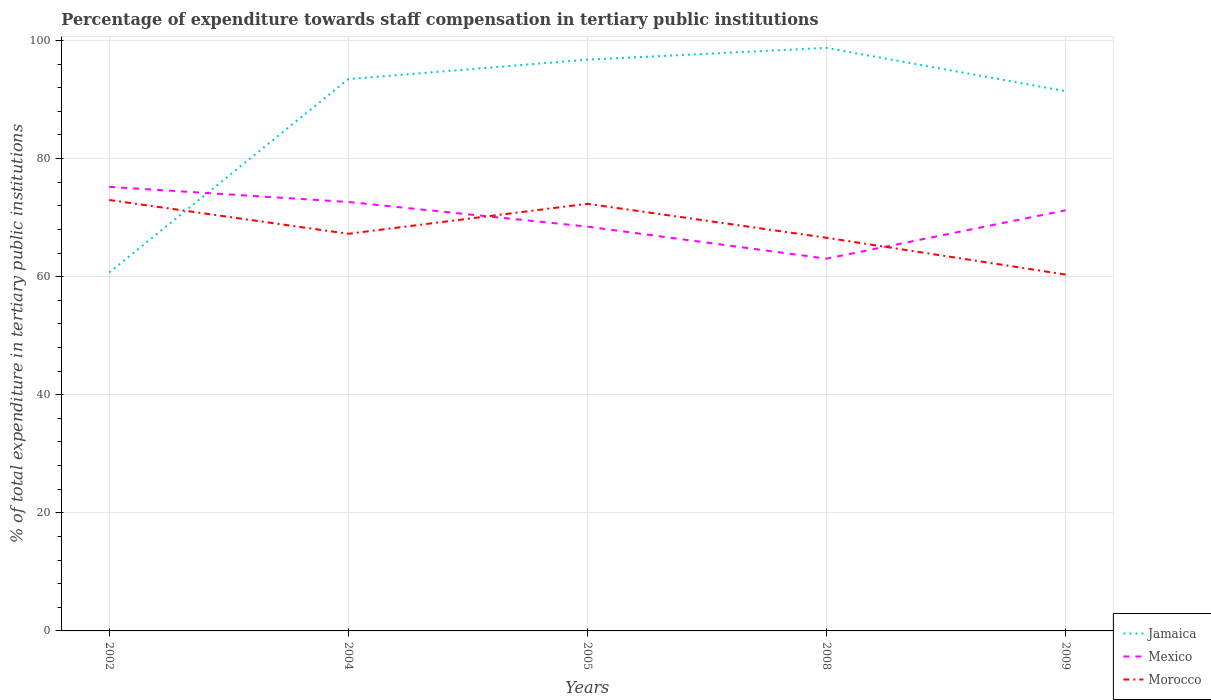How many different coloured lines are there?
Provide a short and direct response. 3. Does the line corresponding to Jamaica intersect with the line corresponding to Morocco?
Provide a short and direct response. Yes. Is the number of lines equal to the number of legend labels?
Offer a very short reply. Yes. Across all years, what is the maximum percentage of expenditure towards staff compensation in Jamaica?
Offer a very short reply. 60.7. What is the total percentage of expenditure towards staff compensation in Mexico in the graph?
Offer a terse response. -2.76. What is the difference between the highest and the second highest percentage of expenditure towards staff compensation in Mexico?
Give a very brief answer. 12.16. How many lines are there?
Your answer should be compact. 3. Are the values on the major ticks of Y-axis written in scientific E-notation?
Your answer should be very brief. No. Does the graph contain any zero values?
Provide a succinct answer. No. Does the graph contain grids?
Give a very brief answer. Yes. How many legend labels are there?
Make the answer very short. 3. What is the title of the graph?
Your response must be concise. Percentage of expenditure towards staff compensation in tertiary public institutions. What is the label or title of the X-axis?
Provide a succinct answer. Years. What is the label or title of the Y-axis?
Provide a succinct answer. % of total expenditure in tertiary public institutions. What is the % of total expenditure in tertiary public institutions in Jamaica in 2002?
Provide a succinct answer. 60.7. What is the % of total expenditure in tertiary public institutions in Mexico in 2002?
Your answer should be compact. 75.21. What is the % of total expenditure in tertiary public institutions in Morocco in 2002?
Offer a very short reply. 72.98. What is the % of total expenditure in tertiary public institutions in Jamaica in 2004?
Provide a succinct answer. 93.46. What is the % of total expenditure in tertiary public institutions in Mexico in 2004?
Provide a succinct answer. 72.65. What is the % of total expenditure in tertiary public institutions in Morocco in 2004?
Offer a terse response. 67.26. What is the % of total expenditure in tertiary public institutions in Jamaica in 2005?
Make the answer very short. 96.75. What is the % of total expenditure in tertiary public institutions of Mexico in 2005?
Make the answer very short. 68.47. What is the % of total expenditure in tertiary public institutions of Morocco in 2005?
Offer a terse response. 72.34. What is the % of total expenditure in tertiary public institutions of Jamaica in 2008?
Give a very brief answer. 98.74. What is the % of total expenditure in tertiary public institutions in Mexico in 2008?
Give a very brief answer. 63.05. What is the % of total expenditure in tertiary public institutions in Morocco in 2008?
Keep it short and to the point. 66.59. What is the % of total expenditure in tertiary public institutions of Jamaica in 2009?
Provide a short and direct response. 91.41. What is the % of total expenditure in tertiary public institutions of Mexico in 2009?
Your response must be concise. 71.23. What is the % of total expenditure in tertiary public institutions in Morocco in 2009?
Your response must be concise. 60.36. Across all years, what is the maximum % of total expenditure in tertiary public institutions in Jamaica?
Your response must be concise. 98.74. Across all years, what is the maximum % of total expenditure in tertiary public institutions of Mexico?
Offer a terse response. 75.21. Across all years, what is the maximum % of total expenditure in tertiary public institutions in Morocco?
Make the answer very short. 72.98. Across all years, what is the minimum % of total expenditure in tertiary public institutions in Jamaica?
Make the answer very short. 60.7. Across all years, what is the minimum % of total expenditure in tertiary public institutions of Mexico?
Make the answer very short. 63.05. Across all years, what is the minimum % of total expenditure in tertiary public institutions in Morocco?
Your response must be concise. 60.36. What is the total % of total expenditure in tertiary public institutions in Jamaica in the graph?
Make the answer very short. 441.06. What is the total % of total expenditure in tertiary public institutions of Mexico in the graph?
Give a very brief answer. 350.61. What is the total % of total expenditure in tertiary public institutions of Morocco in the graph?
Provide a short and direct response. 339.52. What is the difference between the % of total expenditure in tertiary public institutions of Jamaica in 2002 and that in 2004?
Make the answer very short. -32.75. What is the difference between the % of total expenditure in tertiary public institutions in Mexico in 2002 and that in 2004?
Offer a terse response. 2.56. What is the difference between the % of total expenditure in tertiary public institutions of Morocco in 2002 and that in 2004?
Keep it short and to the point. 5.72. What is the difference between the % of total expenditure in tertiary public institutions in Jamaica in 2002 and that in 2005?
Give a very brief answer. -36.05. What is the difference between the % of total expenditure in tertiary public institutions in Mexico in 2002 and that in 2005?
Offer a terse response. 6.74. What is the difference between the % of total expenditure in tertiary public institutions of Morocco in 2002 and that in 2005?
Ensure brevity in your answer.  0.64. What is the difference between the % of total expenditure in tertiary public institutions of Jamaica in 2002 and that in 2008?
Provide a succinct answer. -38.04. What is the difference between the % of total expenditure in tertiary public institutions in Mexico in 2002 and that in 2008?
Provide a succinct answer. 12.16. What is the difference between the % of total expenditure in tertiary public institutions in Morocco in 2002 and that in 2008?
Keep it short and to the point. 6.39. What is the difference between the % of total expenditure in tertiary public institutions in Jamaica in 2002 and that in 2009?
Give a very brief answer. -30.71. What is the difference between the % of total expenditure in tertiary public institutions in Mexico in 2002 and that in 2009?
Offer a very short reply. 3.98. What is the difference between the % of total expenditure in tertiary public institutions of Morocco in 2002 and that in 2009?
Offer a terse response. 12.62. What is the difference between the % of total expenditure in tertiary public institutions of Jamaica in 2004 and that in 2005?
Keep it short and to the point. -3.3. What is the difference between the % of total expenditure in tertiary public institutions in Mexico in 2004 and that in 2005?
Your answer should be compact. 4.17. What is the difference between the % of total expenditure in tertiary public institutions in Morocco in 2004 and that in 2005?
Your answer should be very brief. -5.08. What is the difference between the % of total expenditure in tertiary public institutions of Jamaica in 2004 and that in 2008?
Offer a terse response. -5.28. What is the difference between the % of total expenditure in tertiary public institutions in Mexico in 2004 and that in 2008?
Your answer should be compact. 9.6. What is the difference between the % of total expenditure in tertiary public institutions of Morocco in 2004 and that in 2008?
Provide a short and direct response. 0.67. What is the difference between the % of total expenditure in tertiary public institutions of Jamaica in 2004 and that in 2009?
Your answer should be compact. 2.04. What is the difference between the % of total expenditure in tertiary public institutions in Mexico in 2004 and that in 2009?
Make the answer very short. 1.41. What is the difference between the % of total expenditure in tertiary public institutions in Morocco in 2004 and that in 2009?
Your response must be concise. 6.9. What is the difference between the % of total expenditure in tertiary public institutions in Jamaica in 2005 and that in 2008?
Provide a succinct answer. -1.99. What is the difference between the % of total expenditure in tertiary public institutions in Mexico in 2005 and that in 2008?
Provide a succinct answer. 5.42. What is the difference between the % of total expenditure in tertiary public institutions in Morocco in 2005 and that in 2008?
Your response must be concise. 5.75. What is the difference between the % of total expenditure in tertiary public institutions in Jamaica in 2005 and that in 2009?
Your answer should be very brief. 5.34. What is the difference between the % of total expenditure in tertiary public institutions of Mexico in 2005 and that in 2009?
Provide a succinct answer. -2.76. What is the difference between the % of total expenditure in tertiary public institutions of Morocco in 2005 and that in 2009?
Your response must be concise. 11.98. What is the difference between the % of total expenditure in tertiary public institutions of Jamaica in 2008 and that in 2009?
Offer a terse response. 7.32. What is the difference between the % of total expenditure in tertiary public institutions in Mexico in 2008 and that in 2009?
Provide a succinct answer. -8.18. What is the difference between the % of total expenditure in tertiary public institutions in Morocco in 2008 and that in 2009?
Give a very brief answer. 6.23. What is the difference between the % of total expenditure in tertiary public institutions in Jamaica in 2002 and the % of total expenditure in tertiary public institutions in Mexico in 2004?
Provide a succinct answer. -11.95. What is the difference between the % of total expenditure in tertiary public institutions of Jamaica in 2002 and the % of total expenditure in tertiary public institutions of Morocco in 2004?
Your response must be concise. -6.56. What is the difference between the % of total expenditure in tertiary public institutions in Mexico in 2002 and the % of total expenditure in tertiary public institutions in Morocco in 2004?
Make the answer very short. 7.95. What is the difference between the % of total expenditure in tertiary public institutions in Jamaica in 2002 and the % of total expenditure in tertiary public institutions in Mexico in 2005?
Ensure brevity in your answer.  -7.77. What is the difference between the % of total expenditure in tertiary public institutions in Jamaica in 2002 and the % of total expenditure in tertiary public institutions in Morocco in 2005?
Keep it short and to the point. -11.64. What is the difference between the % of total expenditure in tertiary public institutions in Mexico in 2002 and the % of total expenditure in tertiary public institutions in Morocco in 2005?
Provide a short and direct response. 2.87. What is the difference between the % of total expenditure in tertiary public institutions in Jamaica in 2002 and the % of total expenditure in tertiary public institutions in Mexico in 2008?
Your answer should be very brief. -2.35. What is the difference between the % of total expenditure in tertiary public institutions in Jamaica in 2002 and the % of total expenditure in tertiary public institutions in Morocco in 2008?
Your answer should be very brief. -5.88. What is the difference between the % of total expenditure in tertiary public institutions of Mexico in 2002 and the % of total expenditure in tertiary public institutions of Morocco in 2008?
Ensure brevity in your answer.  8.62. What is the difference between the % of total expenditure in tertiary public institutions in Jamaica in 2002 and the % of total expenditure in tertiary public institutions in Mexico in 2009?
Your response must be concise. -10.53. What is the difference between the % of total expenditure in tertiary public institutions of Jamaica in 2002 and the % of total expenditure in tertiary public institutions of Morocco in 2009?
Your response must be concise. 0.35. What is the difference between the % of total expenditure in tertiary public institutions of Mexico in 2002 and the % of total expenditure in tertiary public institutions of Morocco in 2009?
Your answer should be compact. 14.85. What is the difference between the % of total expenditure in tertiary public institutions in Jamaica in 2004 and the % of total expenditure in tertiary public institutions in Mexico in 2005?
Offer a terse response. 24.98. What is the difference between the % of total expenditure in tertiary public institutions in Jamaica in 2004 and the % of total expenditure in tertiary public institutions in Morocco in 2005?
Keep it short and to the point. 21.12. What is the difference between the % of total expenditure in tertiary public institutions in Mexico in 2004 and the % of total expenditure in tertiary public institutions in Morocco in 2005?
Offer a terse response. 0.31. What is the difference between the % of total expenditure in tertiary public institutions in Jamaica in 2004 and the % of total expenditure in tertiary public institutions in Mexico in 2008?
Give a very brief answer. 30.41. What is the difference between the % of total expenditure in tertiary public institutions of Jamaica in 2004 and the % of total expenditure in tertiary public institutions of Morocco in 2008?
Provide a short and direct response. 26.87. What is the difference between the % of total expenditure in tertiary public institutions in Mexico in 2004 and the % of total expenditure in tertiary public institutions in Morocco in 2008?
Make the answer very short. 6.06. What is the difference between the % of total expenditure in tertiary public institutions of Jamaica in 2004 and the % of total expenditure in tertiary public institutions of Mexico in 2009?
Keep it short and to the point. 22.22. What is the difference between the % of total expenditure in tertiary public institutions of Jamaica in 2004 and the % of total expenditure in tertiary public institutions of Morocco in 2009?
Keep it short and to the point. 33.1. What is the difference between the % of total expenditure in tertiary public institutions in Mexico in 2004 and the % of total expenditure in tertiary public institutions in Morocco in 2009?
Ensure brevity in your answer.  12.29. What is the difference between the % of total expenditure in tertiary public institutions in Jamaica in 2005 and the % of total expenditure in tertiary public institutions in Mexico in 2008?
Give a very brief answer. 33.7. What is the difference between the % of total expenditure in tertiary public institutions in Jamaica in 2005 and the % of total expenditure in tertiary public institutions in Morocco in 2008?
Provide a succinct answer. 30.17. What is the difference between the % of total expenditure in tertiary public institutions in Mexico in 2005 and the % of total expenditure in tertiary public institutions in Morocco in 2008?
Your response must be concise. 1.89. What is the difference between the % of total expenditure in tertiary public institutions in Jamaica in 2005 and the % of total expenditure in tertiary public institutions in Mexico in 2009?
Offer a terse response. 25.52. What is the difference between the % of total expenditure in tertiary public institutions in Jamaica in 2005 and the % of total expenditure in tertiary public institutions in Morocco in 2009?
Give a very brief answer. 36.4. What is the difference between the % of total expenditure in tertiary public institutions of Mexico in 2005 and the % of total expenditure in tertiary public institutions of Morocco in 2009?
Ensure brevity in your answer.  8.12. What is the difference between the % of total expenditure in tertiary public institutions in Jamaica in 2008 and the % of total expenditure in tertiary public institutions in Mexico in 2009?
Give a very brief answer. 27.5. What is the difference between the % of total expenditure in tertiary public institutions in Jamaica in 2008 and the % of total expenditure in tertiary public institutions in Morocco in 2009?
Your answer should be very brief. 38.38. What is the difference between the % of total expenditure in tertiary public institutions of Mexico in 2008 and the % of total expenditure in tertiary public institutions of Morocco in 2009?
Offer a very short reply. 2.69. What is the average % of total expenditure in tertiary public institutions in Jamaica per year?
Give a very brief answer. 88.21. What is the average % of total expenditure in tertiary public institutions of Mexico per year?
Provide a short and direct response. 70.12. What is the average % of total expenditure in tertiary public institutions of Morocco per year?
Provide a short and direct response. 67.9. In the year 2002, what is the difference between the % of total expenditure in tertiary public institutions of Jamaica and % of total expenditure in tertiary public institutions of Mexico?
Your answer should be very brief. -14.51. In the year 2002, what is the difference between the % of total expenditure in tertiary public institutions in Jamaica and % of total expenditure in tertiary public institutions in Morocco?
Your answer should be compact. -12.28. In the year 2002, what is the difference between the % of total expenditure in tertiary public institutions of Mexico and % of total expenditure in tertiary public institutions of Morocco?
Make the answer very short. 2.23. In the year 2004, what is the difference between the % of total expenditure in tertiary public institutions of Jamaica and % of total expenditure in tertiary public institutions of Mexico?
Provide a short and direct response. 20.81. In the year 2004, what is the difference between the % of total expenditure in tertiary public institutions of Jamaica and % of total expenditure in tertiary public institutions of Morocco?
Offer a very short reply. 26.2. In the year 2004, what is the difference between the % of total expenditure in tertiary public institutions in Mexico and % of total expenditure in tertiary public institutions in Morocco?
Your response must be concise. 5.39. In the year 2005, what is the difference between the % of total expenditure in tertiary public institutions of Jamaica and % of total expenditure in tertiary public institutions of Mexico?
Ensure brevity in your answer.  28.28. In the year 2005, what is the difference between the % of total expenditure in tertiary public institutions in Jamaica and % of total expenditure in tertiary public institutions in Morocco?
Make the answer very short. 24.41. In the year 2005, what is the difference between the % of total expenditure in tertiary public institutions in Mexico and % of total expenditure in tertiary public institutions in Morocco?
Offer a very short reply. -3.87. In the year 2008, what is the difference between the % of total expenditure in tertiary public institutions in Jamaica and % of total expenditure in tertiary public institutions in Mexico?
Ensure brevity in your answer.  35.69. In the year 2008, what is the difference between the % of total expenditure in tertiary public institutions in Jamaica and % of total expenditure in tertiary public institutions in Morocco?
Provide a succinct answer. 32.15. In the year 2008, what is the difference between the % of total expenditure in tertiary public institutions in Mexico and % of total expenditure in tertiary public institutions in Morocco?
Offer a terse response. -3.54. In the year 2009, what is the difference between the % of total expenditure in tertiary public institutions of Jamaica and % of total expenditure in tertiary public institutions of Mexico?
Provide a short and direct response. 20.18. In the year 2009, what is the difference between the % of total expenditure in tertiary public institutions in Jamaica and % of total expenditure in tertiary public institutions in Morocco?
Your response must be concise. 31.06. In the year 2009, what is the difference between the % of total expenditure in tertiary public institutions in Mexico and % of total expenditure in tertiary public institutions in Morocco?
Provide a short and direct response. 10.88. What is the ratio of the % of total expenditure in tertiary public institutions of Jamaica in 2002 to that in 2004?
Provide a succinct answer. 0.65. What is the ratio of the % of total expenditure in tertiary public institutions of Mexico in 2002 to that in 2004?
Your answer should be very brief. 1.04. What is the ratio of the % of total expenditure in tertiary public institutions of Morocco in 2002 to that in 2004?
Your response must be concise. 1.08. What is the ratio of the % of total expenditure in tertiary public institutions in Jamaica in 2002 to that in 2005?
Your response must be concise. 0.63. What is the ratio of the % of total expenditure in tertiary public institutions in Mexico in 2002 to that in 2005?
Offer a very short reply. 1.1. What is the ratio of the % of total expenditure in tertiary public institutions in Morocco in 2002 to that in 2005?
Your answer should be very brief. 1.01. What is the ratio of the % of total expenditure in tertiary public institutions in Jamaica in 2002 to that in 2008?
Your response must be concise. 0.61. What is the ratio of the % of total expenditure in tertiary public institutions of Mexico in 2002 to that in 2008?
Make the answer very short. 1.19. What is the ratio of the % of total expenditure in tertiary public institutions in Morocco in 2002 to that in 2008?
Your response must be concise. 1.1. What is the ratio of the % of total expenditure in tertiary public institutions in Jamaica in 2002 to that in 2009?
Your answer should be compact. 0.66. What is the ratio of the % of total expenditure in tertiary public institutions of Mexico in 2002 to that in 2009?
Your response must be concise. 1.06. What is the ratio of the % of total expenditure in tertiary public institutions of Morocco in 2002 to that in 2009?
Give a very brief answer. 1.21. What is the ratio of the % of total expenditure in tertiary public institutions in Jamaica in 2004 to that in 2005?
Your response must be concise. 0.97. What is the ratio of the % of total expenditure in tertiary public institutions in Mexico in 2004 to that in 2005?
Your answer should be compact. 1.06. What is the ratio of the % of total expenditure in tertiary public institutions in Morocco in 2004 to that in 2005?
Provide a succinct answer. 0.93. What is the ratio of the % of total expenditure in tertiary public institutions of Jamaica in 2004 to that in 2008?
Your answer should be very brief. 0.95. What is the ratio of the % of total expenditure in tertiary public institutions of Mexico in 2004 to that in 2008?
Make the answer very short. 1.15. What is the ratio of the % of total expenditure in tertiary public institutions of Morocco in 2004 to that in 2008?
Your answer should be very brief. 1.01. What is the ratio of the % of total expenditure in tertiary public institutions of Jamaica in 2004 to that in 2009?
Keep it short and to the point. 1.02. What is the ratio of the % of total expenditure in tertiary public institutions of Mexico in 2004 to that in 2009?
Make the answer very short. 1.02. What is the ratio of the % of total expenditure in tertiary public institutions in Morocco in 2004 to that in 2009?
Provide a succinct answer. 1.11. What is the ratio of the % of total expenditure in tertiary public institutions of Jamaica in 2005 to that in 2008?
Provide a short and direct response. 0.98. What is the ratio of the % of total expenditure in tertiary public institutions of Mexico in 2005 to that in 2008?
Offer a terse response. 1.09. What is the ratio of the % of total expenditure in tertiary public institutions in Morocco in 2005 to that in 2008?
Keep it short and to the point. 1.09. What is the ratio of the % of total expenditure in tertiary public institutions of Jamaica in 2005 to that in 2009?
Give a very brief answer. 1.06. What is the ratio of the % of total expenditure in tertiary public institutions of Mexico in 2005 to that in 2009?
Your response must be concise. 0.96. What is the ratio of the % of total expenditure in tertiary public institutions in Morocco in 2005 to that in 2009?
Your answer should be very brief. 1.2. What is the ratio of the % of total expenditure in tertiary public institutions in Jamaica in 2008 to that in 2009?
Make the answer very short. 1.08. What is the ratio of the % of total expenditure in tertiary public institutions of Mexico in 2008 to that in 2009?
Give a very brief answer. 0.89. What is the ratio of the % of total expenditure in tertiary public institutions in Morocco in 2008 to that in 2009?
Give a very brief answer. 1.1. What is the difference between the highest and the second highest % of total expenditure in tertiary public institutions of Jamaica?
Your answer should be compact. 1.99. What is the difference between the highest and the second highest % of total expenditure in tertiary public institutions of Mexico?
Offer a terse response. 2.56. What is the difference between the highest and the second highest % of total expenditure in tertiary public institutions in Morocco?
Offer a very short reply. 0.64. What is the difference between the highest and the lowest % of total expenditure in tertiary public institutions of Jamaica?
Offer a very short reply. 38.04. What is the difference between the highest and the lowest % of total expenditure in tertiary public institutions in Mexico?
Provide a short and direct response. 12.16. What is the difference between the highest and the lowest % of total expenditure in tertiary public institutions in Morocco?
Give a very brief answer. 12.62. 